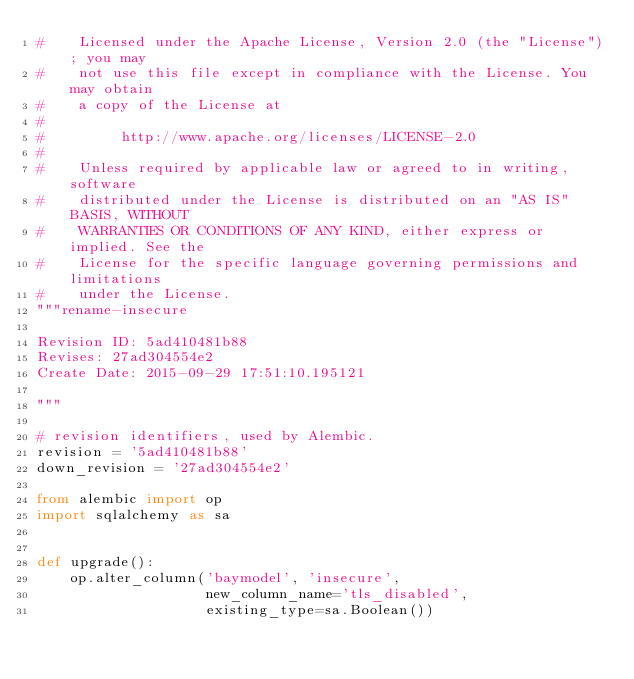Convert code to text. <code><loc_0><loc_0><loc_500><loc_500><_Python_>#    Licensed under the Apache License, Version 2.0 (the "License"); you may
#    not use this file except in compliance with the License. You may obtain
#    a copy of the License at
#
#         http://www.apache.org/licenses/LICENSE-2.0
#
#    Unless required by applicable law or agreed to in writing, software
#    distributed under the License is distributed on an "AS IS" BASIS, WITHOUT
#    WARRANTIES OR CONDITIONS OF ANY KIND, either express or implied. See the
#    License for the specific language governing permissions and limitations
#    under the License.
"""rename-insecure

Revision ID: 5ad410481b88
Revises: 27ad304554e2
Create Date: 2015-09-29 17:51:10.195121

"""

# revision identifiers, used by Alembic.
revision = '5ad410481b88'
down_revision = '27ad304554e2'

from alembic import op
import sqlalchemy as sa


def upgrade():
    op.alter_column('baymodel', 'insecure',
                    new_column_name='tls_disabled',
                    existing_type=sa.Boolean())
</code> 